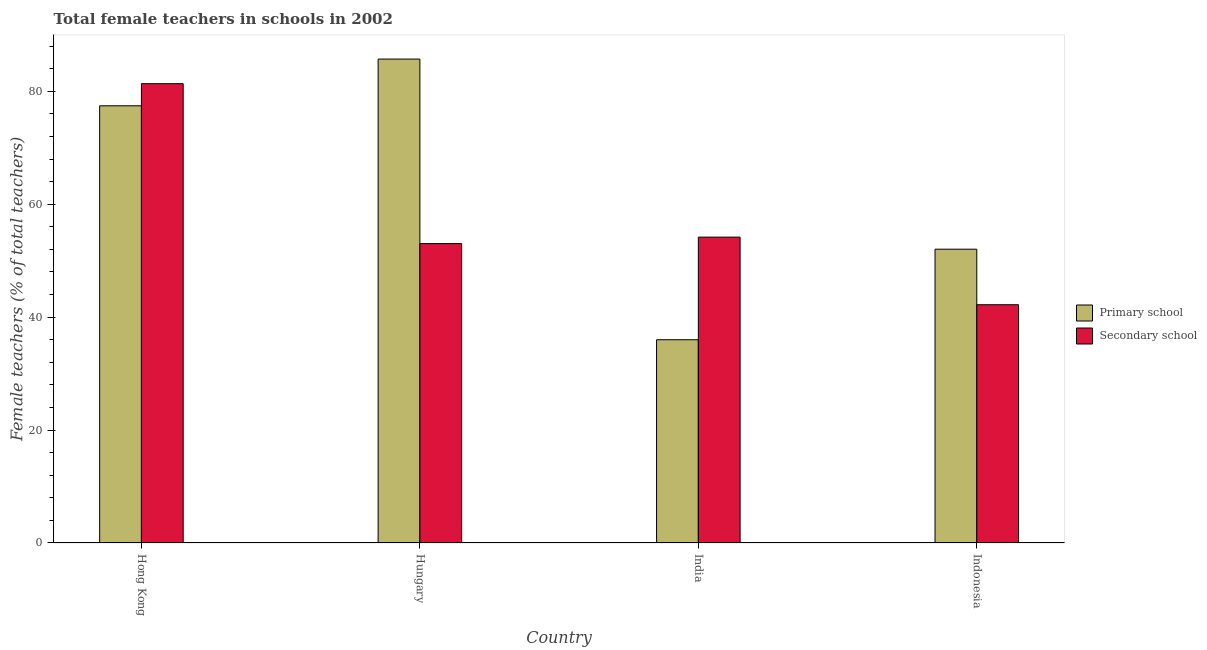How many different coloured bars are there?
Your answer should be compact. 2. How many groups of bars are there?
Give a very brief answer. 4. Are the number of bars per tick equal to the number of legend labels?
Ensure brevity in your answer.  Yes. Are the number of bars on each tick of the X-axis equal?
Ensure brevity in your answer.  Yes. How many bars are there on the 1st tick from the left?
Make the answer very short. 2. What is the percentage of female teachers in primary schools in India?
Offer a very short reply. 36. Across all countries, what is the maximum percentage of female teachers in secondary schools?
Ensure brevity in your answer.  81.35. Across all countries, what is the minimum percentage of female teachers in secondary schools?
Make the answer very short. 42.2. In which country was the percentage of female teachers in primary schools maximum?
Your response must be concise. Hungary. What is the total percentage of female teachers in primary schools in the graph?
Offer a terse response. 251.19. What is the difference between the percentage of female teachers in primary schools in Hungary and that in India?
Give a very brief answer. 49.71. What is the difference between the percentage of female teachers in primary schools in Hungary and the percentage of female teachers in secondary schools in Hong Kong?
Your response must be concise. 4.36. What is the average percentage of female teachers in secondary schools per country?
Offer a terse response. 57.69. What is the difference between the percentage of female teachers in primary schools and percentage of female teachers in secondary schools in Indonesia?
Your response must be concise. 9.84. What is the ratio of the percentage of female teachers in primary schools in Hungary to that in India?
Give a very brief answer. 2.38. What is the difference between the highest and the second highest percentage of female teachers in secondary schools?
Ensure brevity in your answer.  27.18. What is the difference between the highest and the lowest percentage of female teachers in primary schools?
Ensure brevity in your answer.  49.71. What does the 2nd bar from the left in Indonesia represents?
Ensure brevity in your answer.  Secondary school. What does the 1st bar from the right in Hong Kong represents?
Provide a succinct answer. Secondary school. How many countries are there in the graph?
Provide a short and direct response. 4. Does the graph contain any zero values?
Offer a terse response. No. Where does the legend appear in the graph?
Provide a short and direct response. Center right. How are the legend labels stacked?
Your response must be concise. Vertical. What is the title of the graph?
Make the answer very short. Total female teachers in schools in 2002. Does "Female entrants" appear as one of the legend labels in the graph?
Offer a terse response. No. What is the label or title of the X-axis?
Offer a terse response. Country. What is the label or title of the Y-axis?
Provide a succinct answer. Female teachers (% of total teachers). What is the Female teachers (% of total teachers) in Primary school in Hong Kong?
Ensure brevity in your answer.  77.44. What is the Female teachers (% of total teachers) in Secondary school in Hong Kong?
Give a very brief answer. 81.35. What is the Female teachers (% of total teachers) of Primary school in Hungary?
Keep it short and to the point. 85.71. What is the Female teachers (% of total teachers) in Secondary school in Hungary?
Offer a terse response. 53.03. What is the Female teachers (% of total teachers) in Primary school in India?
Provide a succinct answer. 36. What is the Female teachers (% of total teachers) in Secondary school in India?
Provide a succinct answer. 54.17. What is the Female teachers (% of total teachers) of Primary school in Indonesia?
Your answer should be compact. 52.04. What is the Female teachers (% of total teachers) in Secondary school in Indonesia?
Offer a very short reply. 42.2. Across all countries, what is the maximum Female teachers (% of total teachers) in Primary school?
Your answer should be compact. 85.71. Across all countries, what is the maximum Female teachers (% of total teachers) of Secondary school?
Your answer should be very brief. 81.35. Across all countries, what is the minimum Female teachers (% of total teachers) in Primary school?
Make the answer very short. 36. Across all countries, what is the minimum Female teachers (% of total teachers) of Secondary school?
Provide a short and direct response. 42.2. What is the total Female teachers (% of total teachers) of Primary school in the graph?
Provide a succinct answer. 251.19. What is the total Female teachers (% of total teachers) of Secondary school in the graph?
Your answer should be very brief. 230.76. What is the difference between the Female teachers (% of total teachers) in Primary school in Hong Kong and that in Hungary?
Provide a succinct answer. -8.28. What is the difference between the Female teachers (% of total teachers) of Secondary school in Hong Kong and that in Hungary?
Offer a terse response. 28.32. What is the difference between the Female teachers (% of total teachers) of Primary school in Hong Kong and that in India?
Make the answer very short. 41.44. What is the difference between the Female teachers (% of total teachers) of Secondary school in Hong Kong and that in India?
Offer a very short reply. 27.18. What is the difference between the Female teachers (% of total teachers) in Primary school in Hong Kong and that in Indonesia?
Your answer should be compact. 25.4. What is the difference between the Female teachers (% of total teachers) in Secondary school in Hong Kong and that in Indonesia?
Give a very brief answer. 39.15. What is the difference between the Female teachers (% of total teachers) in Primary school in Hungary and that in India?
Ensure brevity in your answer.  49.71. What is the difference between the Female teachers (% of total teachers) of Secondary school in Hungary and that in India?
Your answer should be compact. -1.14. What is the difference between the Female teachers (% of total teachers) of Primary school in Hungary and that in Indonesia?
Your answer should be very brief. 33.67. What is the difference between the Female teachers (% of total teachers) of Secondary school in Hungary and that in Indonesia?
Provide a short and direct response. 10.83. What is the difference between the Female teachers (% of total teachers) of Primary school in India and that in Indonesia?
Offer a very short reply. -16.04. What is the difference between the Female teachers (% of total teachers) in Secondary school in India and that in Indonesia?
Your answer should be compact. 11.97. What is the difference between the Female teachers (% of total teachers) in Primary school in Hong Kong and the Female teachers (% of total teachers) in Secondary school in Hungary?
Provide a short and direct response. 24.41. What is the difference between the Female teachers (% of total teachers) in Primary school in Hong Kong and the Female teachers (% of total teachers) in Secondary school in India?
Provide a short and direct response. 23.26. What is the difference between the Female teachers (% of total teachers) in Primary school in Hong Kong and the Female teachers (% of total teachers) in Secondary school in Indonesia?
Keep it short and to the point. 35.23. What is the difference between the Female teachers (% of total teachers) of Primary school in Hungary and the Female teachers (% of total teachers) of Secondary school in India?
Ensure brevity in your answer.  31.54. What is the difference between the Female teachers (% of total teachers) in Primary school in Hungary and the Female teachers (% of total teachers) in Secondary school in Indonesia?
Give a very brief answer. 43.51. What is the difference between the Female teachers (% of total teachers) in Primary school in India and the Female teachers (% of total teachers) in Secondary school in Indonesia?
Ensure brevity in your answer.  -6.2. What is the average Female teachers (% of total teachers) of Primary school per country?
Provide a succinct answer. 62.8. What is the average Female teachers (% of total teachers) in Secondary school per country?
Offer a very short reply. 57.69. What is the difference between the Female teachers (% of total teachers) in Primary school and Female teachers (% of total teachers) in Secondary school in Hong Kong?
Provide a succinct answer. -3.92. What is the difference between the Female teachers (% of total teachers) of Primary school and Female teachers (% of total teachers) of Secondary school in Hungary?
Offer a very short reply. 32.68. What is the difference between the Female teachers (% of total teachers) of Primary school and Female teachers (% of total teachers) of Secondary school in India?
Keep it short and to the point. -18.17. What is the difference between the Female teachers (% of total teachers) in Primary school and Female teachers (% of total teachers) in Secondary school in Indonesia?
Make the answer very short. 9.84. What is the ratio of the Female teachers (% of total teachers) of Primary school in Hong Kong to that in Hungary?
Ensure brevity in your answer.  0.9. What is the ratio of the Female teachers (% of total teachers) in Secondary school in Hong Kong to that in Hungary?
Provide a short and direct response. 1.53. What is the ratio of the Female teachers (% of total teachers) in Primary school in Hong Kong to that in India?
Provide a short and direct response. 2.15. What is the ratio of the Female teachers (% of total teachers) in Secondary school in Hong Kong to that in India?
Provide a succinct answer. 1.5. What is the ratio of the Female teachers (% of total teachers) of Primary school in Hong Kong to that in Indonesia?
Provide a succinct answer. 1.49. What is the ratio of the Female teachers (% of total teachers) in Secondary school in Hong Kong to that in Indonesia?
Make the answer very short. 1.93. What is the ratio of the Female teachers (% of total teachers) in Primary school in Hungary to that in India?
Offer a very short reply. 2.38. What is the ratio of the Female teachers (% of total teachers) in Secondary school in Hungary to that in India?
Provide a succinct answer. 0.98. What is the ratio of the Female teachers (% of total teachers) of Primary school in Hungary to that in Indonesia?
Give a very brief answer. 1.65. What is the ratio of the Female teachers (% of total teachers) in Secondary school in Hungary to that in Indonesia?
Give a very brief answer. 1.26. What is the ratio of the Female teachers (% of total teachers) in Primary school in India to that in Indonesia?
Make the answer very short. 0.69. What is the ratio of the Female teachers (% of total teachers) of Secondary school in India to that in Indonesia?
Ensure brevity in your answer.  1.28. What is the difference between the highest and the second highest Female teachers (% of total teachers) of Primary school?
Offer a terse response. 8.28. What is the difference between the highest and the second highest Female teachers (% of total teachers) of Secondary school?
Provide a succinct answer. 27.18. What is the difference between the highest and the lowest Female teachers (% of total teachers) in Primary school?
Offer a very short reply. 49.71. What is the difference between the highest and the lowest Female teachers (% of total teachers) of Secondary school?
Provide a succinct answer. 39.15. 